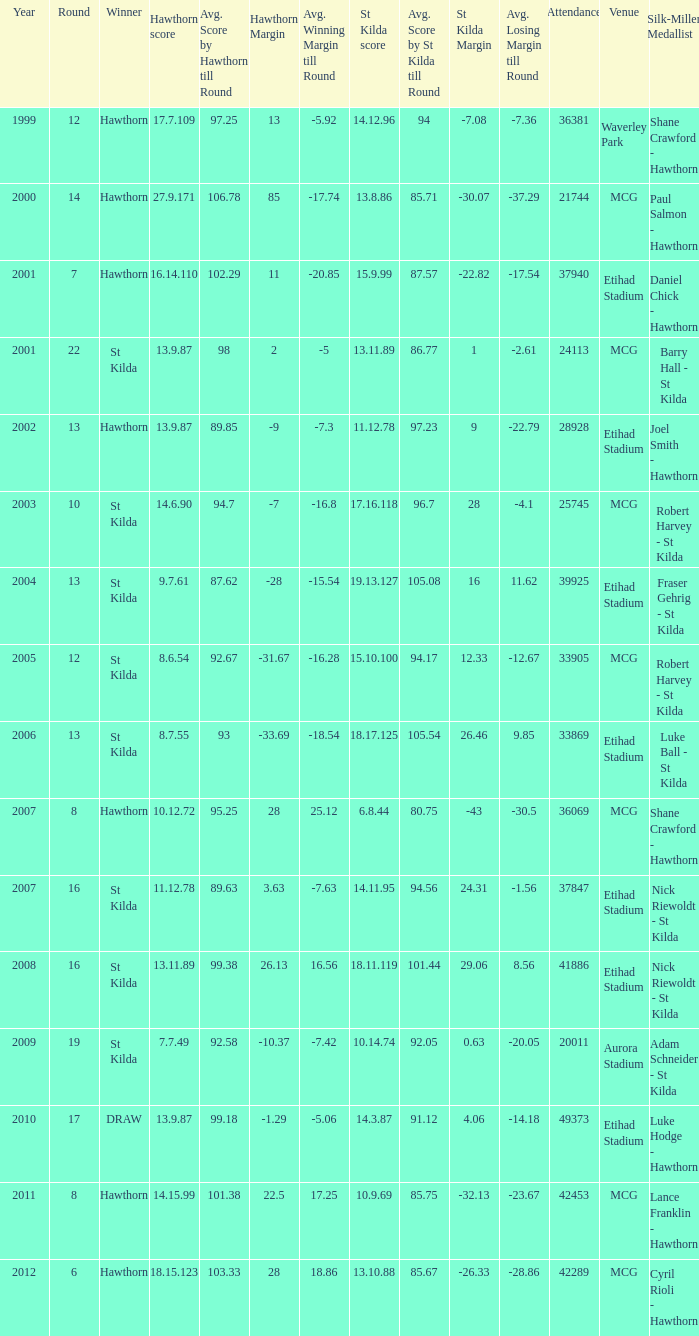What the listed in round when the hawthorn score is 17.7.109? 12.0. 